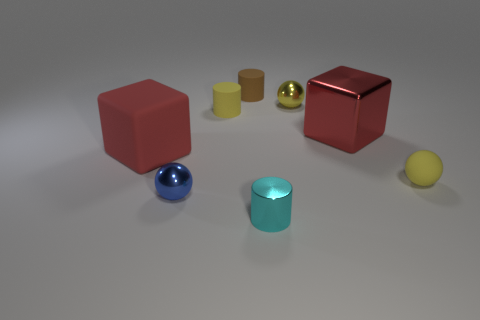Is the number of cyan metallic objects that are behind the tiny brown matte thing the same as the number of large cubes that are behind the red metallic block?
Make the answer very short. Yes. There is a red thing that is in front of the large object that is right of the yellow cylinder; what shape is it?
Your answer should be compact. Cube. Is there a small green thing that has the same shape as the blue shiny object?
Ensure brevity in your answer.  No. How many rubber cylinders are there?
Offer a very short reply. 2. Is the material of the big thing that is right of the tiny brown object the same as the cyan cylinder?
Give a very brief answer. Yes. Are there any other yellow matte cylinders of the same size as the yellow cylinder?
Your answer should be very brief. No. Is the shape of the blue object the same as the red object that is on the left side of the small yellow cylinder?
Make the answer very short. No. There is a small yellow sphere that is left of the yellow sphere in front of the large metallic object; is there a big shiny block that is behind it?
Offer a very short reply. No. What size is the brown matte cylinder?
Give a very brief answer. Small. What number of other objects are there of the same color as the large matte cube?
Ensure brevity in your answer.  1. 